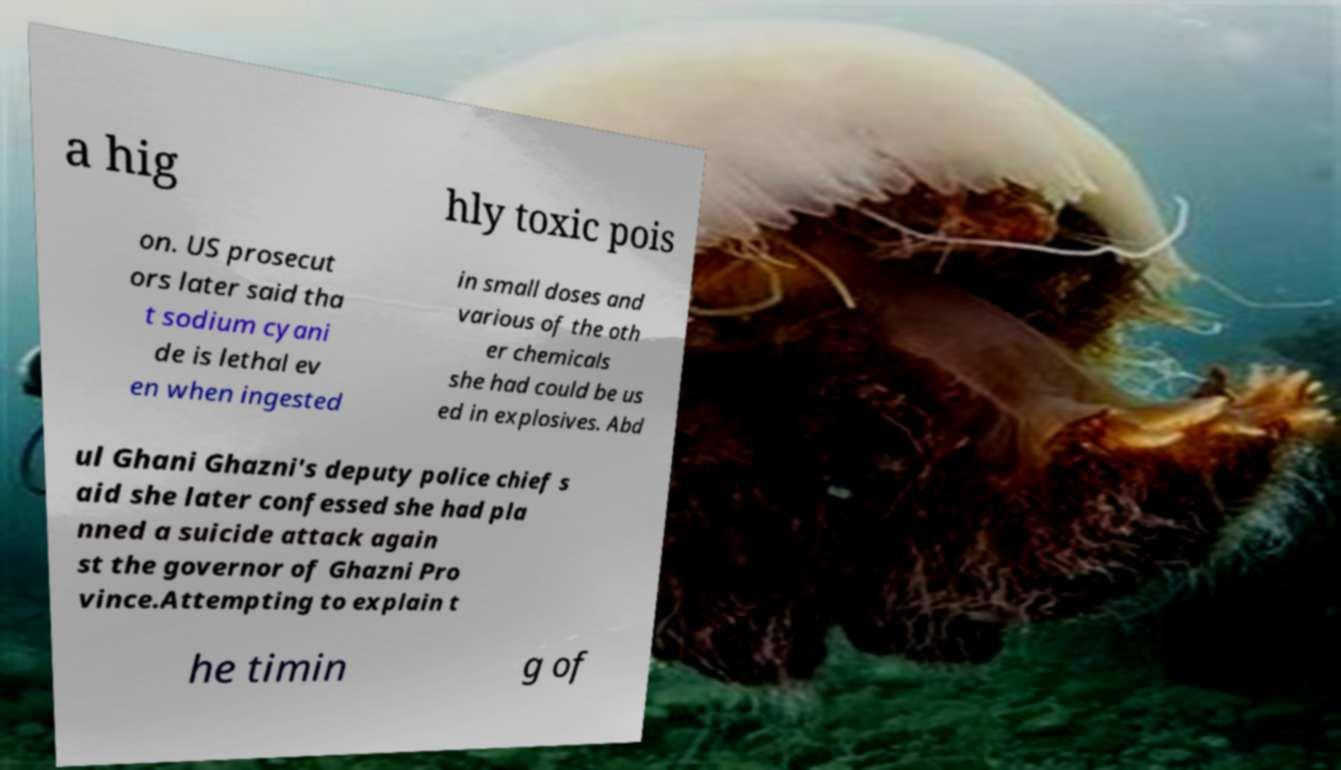Can you accurately transcribe the text from the provided image for me? a hig hly toxic pois on. US prosecut ors later said tha t sodium cyani de is lethal ev en when ingested in small doses and various of the oth er chemicals she had could be us ed in explosives. Abd ul Ghani Ghazni's deputy police chief s aid she later confessed she had pla nned a suicide attack again st the governor of Ghazni Pro vince.Attempting to explain t he timin g of 